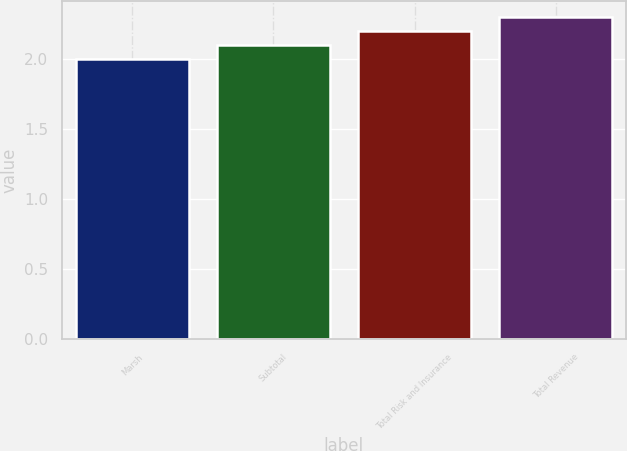Convert chart. <chart><loc_0><loc_0><loc_500><loc_500><bar_chart><fcel>Marsh<fcel>Subtotal<fcel>Total Risk and Insurance<fcel>Total Revenue<nl><fcel>2<fcel>2.1<fcel>2.2<fcel>2.3<nl></chart> 